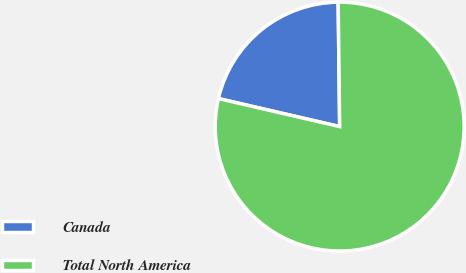<chart> <loc_0><loc_0><loc_500><loc_500><pie_chart><fcel>Canada<fcel>Total North America<nl><fcel>21.19%<fcel>78.81%<nl></chart> 